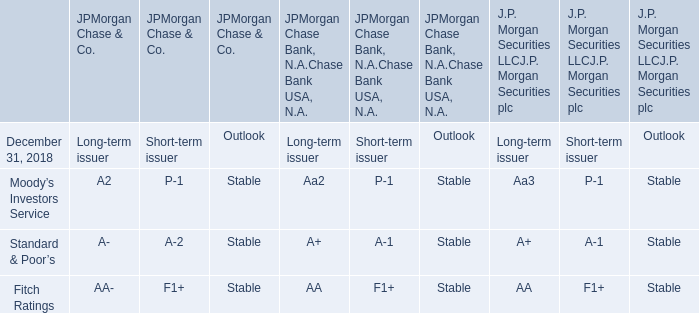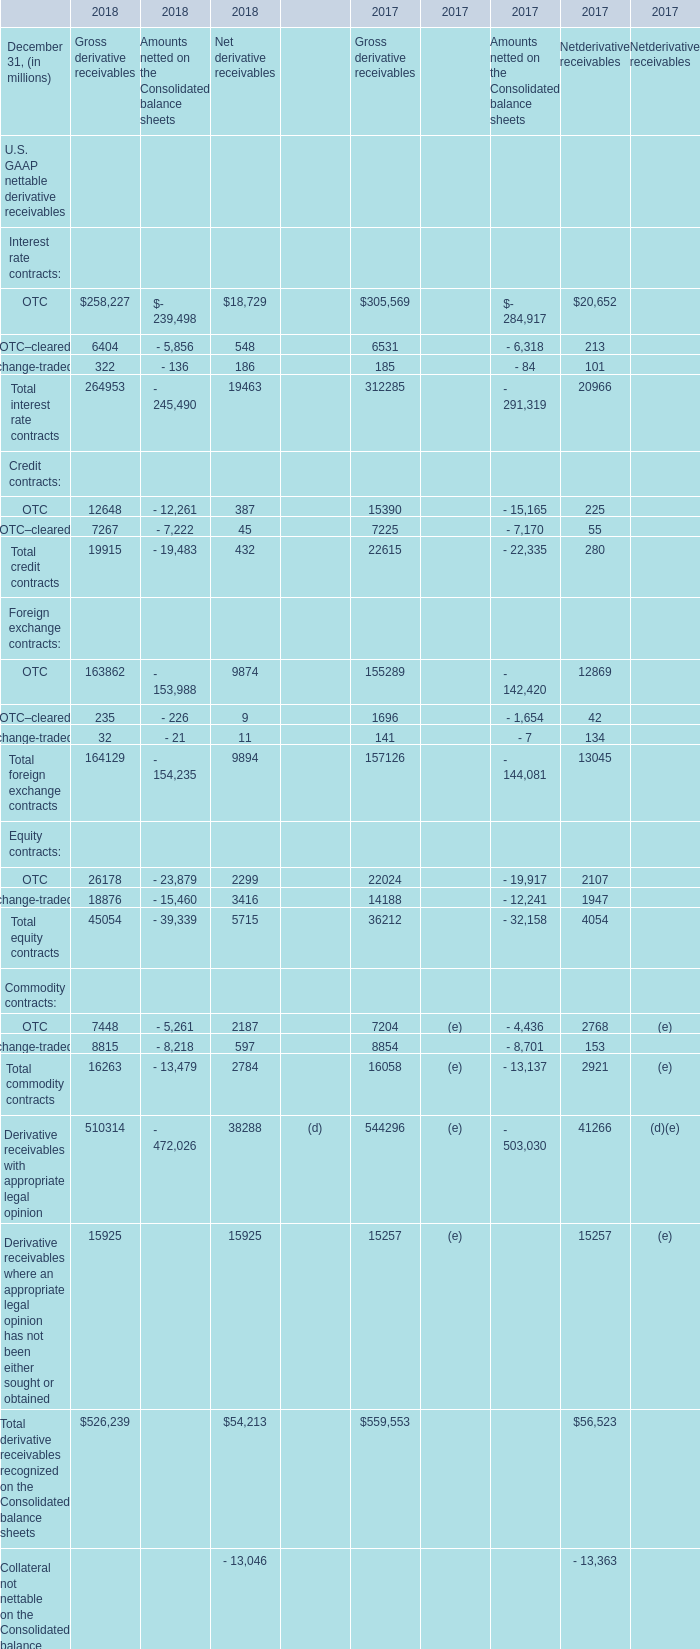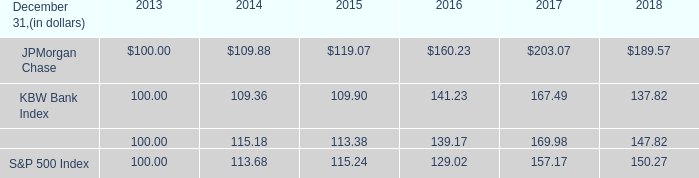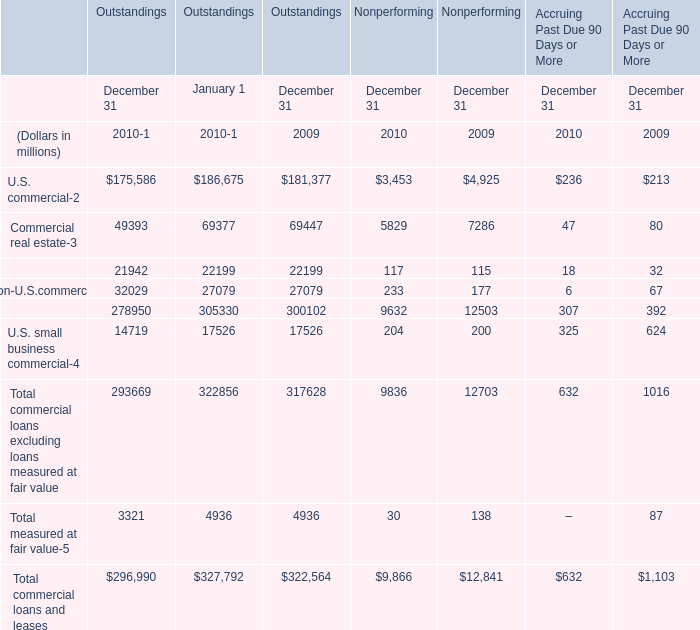What's the average of Commercial real estate of Outstandings December 31 2010, and OTC–cleared of 2018 Gross derivative receivables ? 
Computations: ((49393.0 + 6404.0) / 2)
Answer: 27898.5. 